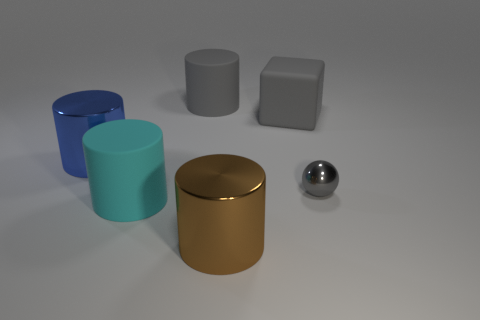How many other things are there of the same color as the large block? Including the large block itself, there are two objects of a similar gray color. It's worth noting that colors might be perceived slightly differently due to lighting and shadow effects, so the objects in question are the gray block and the silver sphere. 